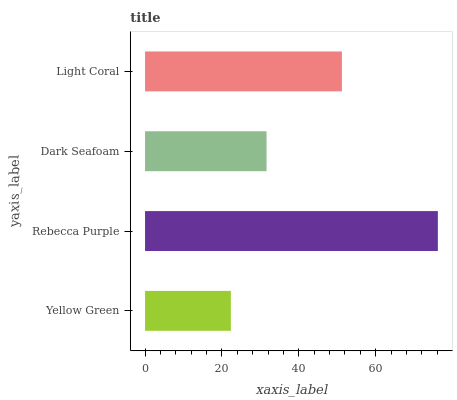Is Yellow Green the minimum?
Answer yes or no. Yes. Is Rebecca Purple the maximum?
Answer yes or no. Yes. Is Dark Seafoam the minimum?
Answer yes or no. No. Is Dark Seafoam the maximum?
Answer yes or no. No. Is Rebecca Purple greater than Dark Seafoam?
Answer yes or no. Yes. Is Dark Seafoam less than Rebecca Purple?
Answer yes or no. Yes. Is Dark Seafoam greater than Rebecca Purple?
Answer yes or no. No. Is Rebecca Purple less than Dark Seafoam?
Answer yes or no. No. Is Light Coral the high median?
Answer yes or no. Yes. Is Dark Seafoam the low median?
Answer yes or no. Yes. Is Yellow Green the high median?
Answer yes or no. No. Is Yellow Green the low median?
Answer yes or no. No. 